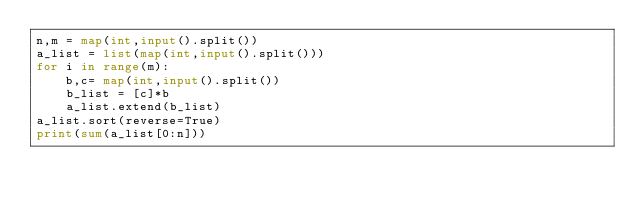<code> <loc_0><loc_0><loc_500><loc_500><_Python_>n,m = map(int,input().split())
a_list = list(map(int,input().split()))
for i in range(m):
    b,c= map(int,input().split())
    b_list = [c]*b
    a_list.extend(b_list)
a_list.sort(reverse=True)
print(sum(a_list[0:n]))
</code> 